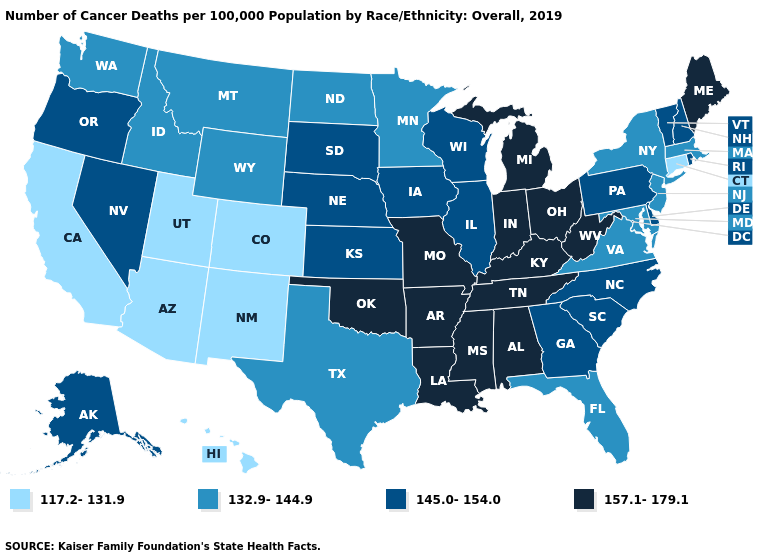What is the lowest value in states that border Oregon?
Give a very brief answer. 117.2-131.9. What is the lowest value in states that border Washington?
Quick response, please. 132.9-144.9. What is the value of California?
Give a very brief answer. 117.2-131.9. Name the states that have a value in the range 117.2-131.9?
Write a very short answer. Arizona, California, Colorado, Connecticut, Hawaii, New Mexico, Utah. What is the value of Maine?
Write a very short answer. 157.1-179.1. Which states hav the highest value in the South?
Concise answer only. Alabama, Arkansas, Kentucky, Louisiana, Mississippi, Oklahoma, Tennessee, West Virginia. Among the states that border Michigan , does Wisconsin have the lowest value?
Concise answer only. Yes. What is the value of New Jersey?
Answer briefly. 132.9-144.9. What is the value of New Mexico?
Be succinct. 117.2-131.9. Name the states that have a value in the range 117.2-131.9?
Concise answer only. Arizona, California, Colorado, Connecticut, Hawaii, New Mexico, Utah. What is the value of Iowa?
Quick response, please. 145.0-154.0. How many symbols are there in the legend?
Concise answer only. 4. What is the value of Alaska?
Be succinct. 145.0-154.0. What is the value of Alabama?
Be succinct. 157.1-179.1. Name the states that have a value in the range 145.0-154.0?
Quick response, please. Alaska, Delaware, Georgia, Illinois, Iowa, Kansas, Nebraska, Nevada, New Hampshire, North Carolina, Oregon, Pennsylvania, Rhode Island, South Carolina, South Dakota, Vermont, Wisconsin. 